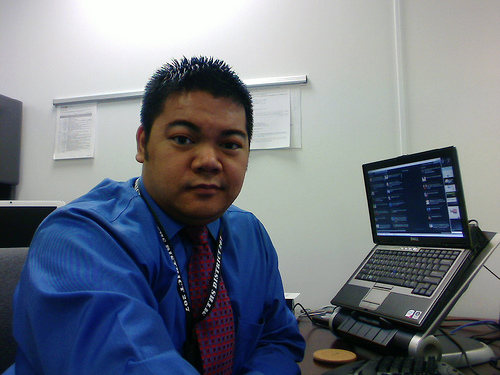<image>Why is the other man mad? It is ambiguous why the other man is mad. He might not be mad at all or it's possibly related to work. Why is the other man mad? I am not sure why the other man is mad. It can be because he's not at work, lost his job or for some other reason. 